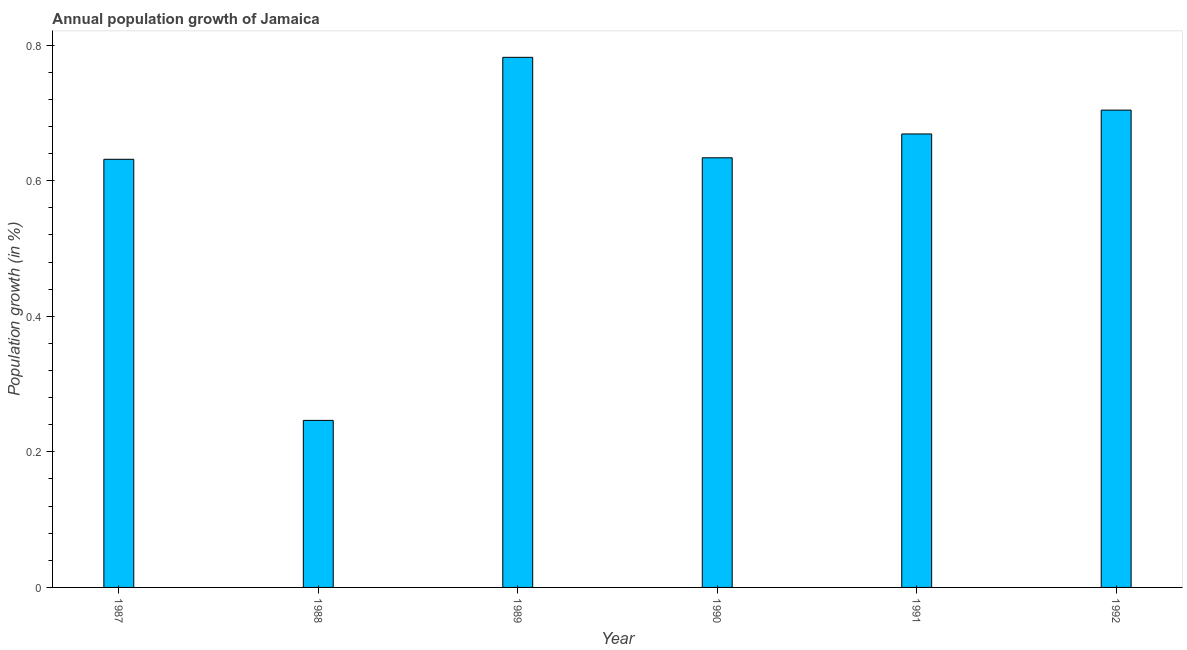Does the graph contain any zero values?
Offer a very short reply. No. Does the graph contain grids?
Your answer should be very brief. No. What is the title of the graph?
Offer a terse response. Annual population growth of Jamaica. What is the label or title of the X-axis?
Your answer should be very brief. Year. What is the label or title of the Y-axis?
Offer a very short reply. Population growth (in %). What is the population growth in 1987?
Provide a succinct answer. 0.63. Across all years, what is the maximum population growth?
Provide a short and direct response. 0.78. Across all years, what is the minimum population growth?
Offer a very short reply. 0.25. What is the sum of the population growth?
Keep it short and to the point. 3.67. What is the difference between the population growth in 1988 and 1989?
Your answer should be very brief. -0.54. What is the average population growth per year?
Your answer should be compact. 0.61. What is the median population growth?
Make the answer very short. 0.65. What is the ratio of the population growth in 1987 to that in 1989?
Your answer should be very brief. 0.81. Is the difference between the population growth in 1987 and 1991 greater than the difference between any two years?
Offer a terse response. No. What is the difference between the highest and the second highest population growth?
Your response must be concise. 0.08. Is the sum of the population growth in 1991 and 1992 greater than the maximum population growth across all years?
Offer a terse response. Yes. What is the difference between the highest and the lowest population growth?
Your answer should be very brief. 0.54. In how many years, is the population growth greater than the average population growth taken over all years?
Offer a terse response. 5. What is the difference between two consecutive major ticks on the Y-axis?
Ensure brevity in your answer.  0.2. What is the Population growth (in %) of 1987?
Offer a terse response. 0.63. What is the Population growth (in %) of 1988?
Your response must be concise. 0.25. What is the Population growth (in %) in 1989?
Offer a terse response. 0.78. What is the Population growth (in %) in 1990?
Offer a terse response. 0.63. What is the Population growth (in %) of 1991?
Your answer should be very brief. 0.67. What is the Population growth (in %) in 1992?
Offer a very short reply. 0.7. What is the difference between the Population growth (in %) in 1987 and 1988?
Give a very brief answer. 0.39. What is the difference between the Population growth (in %) in 1987 and 1989?
Give a very brief answer. -0.15. What is the difference between the Population growth (in %) in 1987 and 1990?
Offer a terse response. -0. What is the difference between the Population growth (in %) in 1987 and 1991?
Offer a terse response. -0.04. What is the difference between the Population growth (in %) in 1987 and 1992?
Your response must be concise. -0.07. What is the difference between the Population growth (in %) in 1988 and 1989?
Your answer should be compact. -0.54. What is the difference between the Population growth (in %) in 1988 and 1990?
Provide a short and direct response. -0.39. What is the difference between the Population growth (in %) in 1988 and 1991?
Your answer should be very brief. -0.42. What is the difference between the Population growth (in %) in 1988 and 1992?
Make the answer very short. -0.46. What is the difference between the Population growth (in %) in 1989 and 1990?
Make the answer very short. 0.15. What is the difference between the Population growth (in %) in 1989 and 1991?
Your answer should be very brief. 0.11. What is the difference between the Population growth (in %) in 1989 and 1992?
Offer a terse response. 0.08. What is the difference between the Population growth (in %) in 1990 and 1991?
Your response must be concise. -0.04. What is the difference between the Population growth (in %) in 1990 and 1992?
Keep it short and to the point. -0.07. What is the difference between the Population growth (in %) in 1991 and 1992?
Make the answer very short. -0.04. What is the ratio of the Population growth (in %) in 1987 to that in 1988?
Your answer should be compact. 2.56. What is the ratio of the Population growth (in %) in 1987 to that in 1989?
Your response must be concise. 0.81. What is the ratio of the Population growth (in %) in 1987 to that in 1991?
Make the answer very short. 0.94. What is the ratio of the Population growth (in %) in 1987 to that in 1992?
Provide a short and direct response. 0.9. What is the ratio of the Population growth (in %) in 1988 to that in 1989?
Your answer should be very brief. 0.32. What is the ratio of the Population growth (in %) in 1988 to that in 1990?
Ensure brevity in your answer.  0.39. What is the ratio of the Population growth (in %) in 1988 to that in 1991?
Keep it short and to the point. 0.37. What is the ratio of the Population growth (in %) in 1988 to that in 1992?
Your answer should be compact. 0.35. What is the ratio of the Population growth (in %) in 1989 to that in 1990?
Ensure brevity in your answer.  1.23. What is the ratio of the Population growth (in %) in 1989 to that in 1991?
Provide a short and direct response. 1.17. What is the ratio of the Population growth (in %) in 1989 to that in 1992?
Ensure brevity in your answer.  1.11. What is the ratio of the Population growth (in %) in 1990 to that in 1991?
Provide a succinct answer. 0.95. What is the ratio of the Population growth (in %) in 1991 to that in 1992?
Make the answer very short. 0.95. 